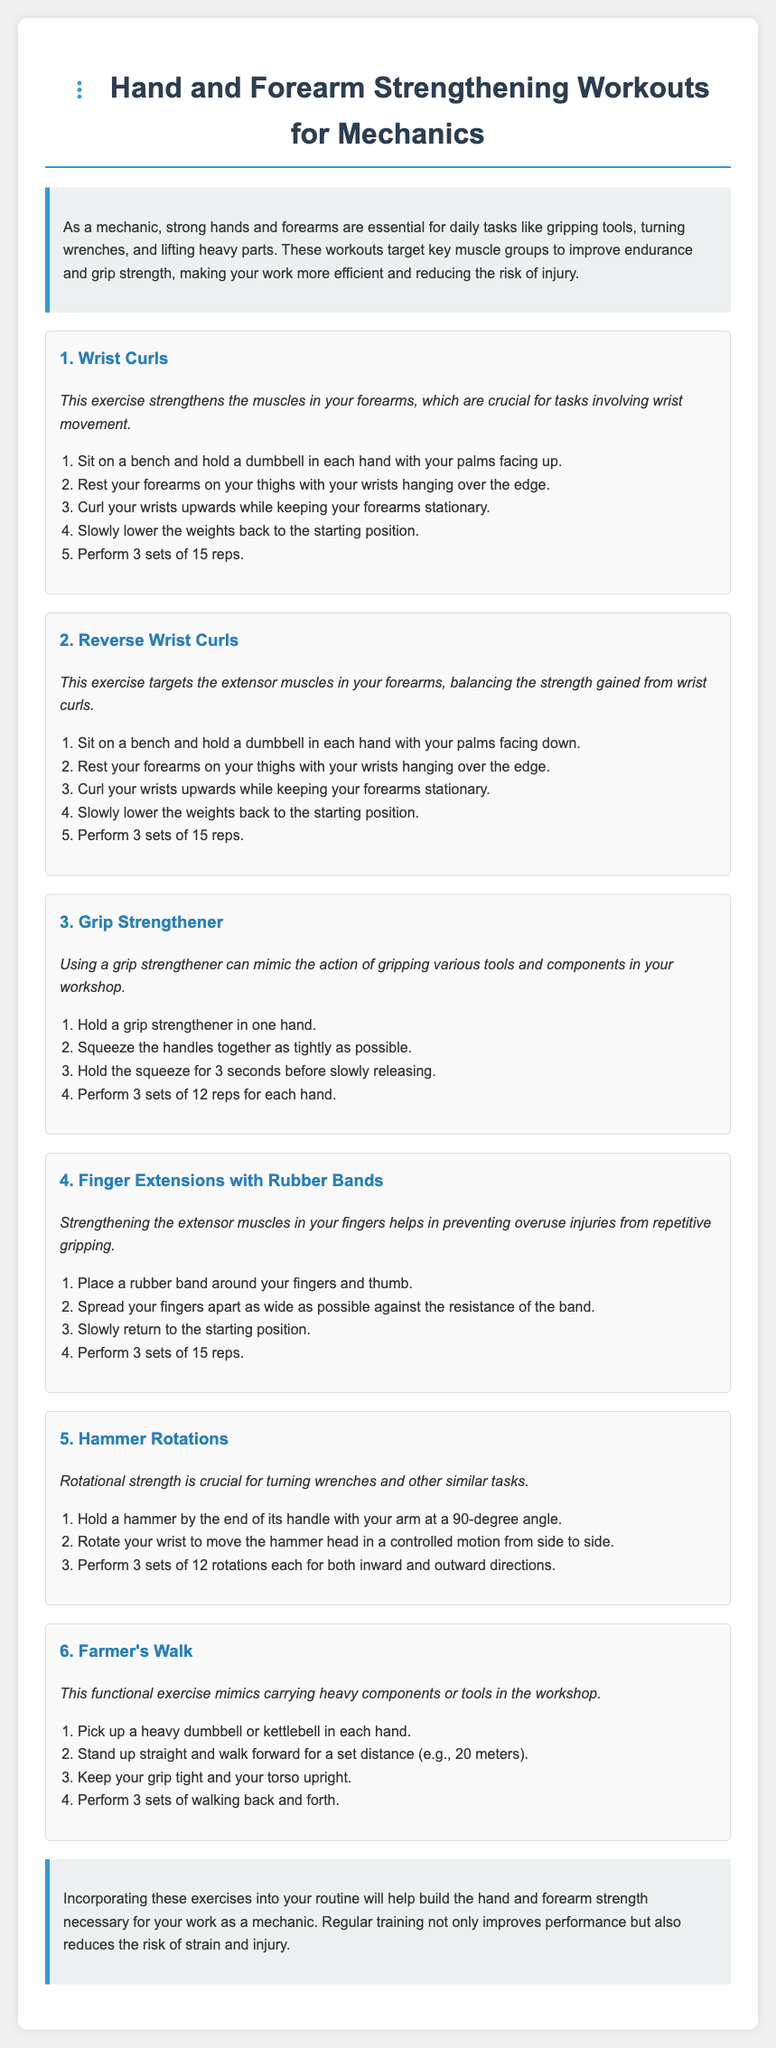what is the title of the document? The title is indicated at the top of the document in the heading.
Answer: Hand and Forearm Strengthening Workouts for Mechanics how many exercises are listed in the document? The number of exercises is counted in the workout sections provided in the document.
Answer: 6 what is the first exercise mentioned? The first exercise appears at the beginning of the workout list.
Answer: Wrist Curls how many sets and reps are recommended for wrist curls? The recommended sets and reps for wrist curls are mentioned in the exercise description.
Answer: 3 sets of 15 reps what is the purpose of finger extensions with rubber bands? The purpose is explained in the paragraph accompanying the exercise.
Answer: Preventing overuse injuries which exercise involves carrying heavy components? This exercise is described in the title and introduction of the corresponding section.
Answer: Farmer's Walk what tool is used in the hammer rotations exercise? The tool is specified in the exercise description under the workout section.
Answer: Hammer how does grip strengthener mimic workshop actions? The mimicking function is briefly explained next to grip strengthener instructions.
Answer: Gripping various tools and components what is the benefit of strengthening the extensor muscles? This benefit is stated in the rationale provided for a specific exercise.
Answer: Preventing overuse injuries 